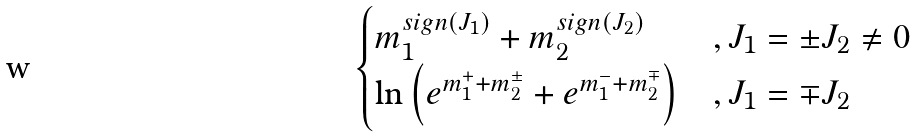Convert formula to latex. <formula><loc_0><loc_0><loc_500><loc_500>\begin{cases} m _ { 1 } ^ { s i g n ( J _ { 1 } ) } + m _ { 2 } ^ { s i g n ( J _ { 2 } ) } & , J _ { 1 } = \pm J _ { 2 } \not = 0 \\ \ln \left ( e ^ { m _ { 1 } ^ { + } + m _ { 2 } ^ { \pm } } + e ^ { m _ { 1 } ^ { - } + m _ { 2 } ^ { \mp } } \right ) & , J _ { 1 } = \mp J _ { 2 } \end{cases}</formula> 